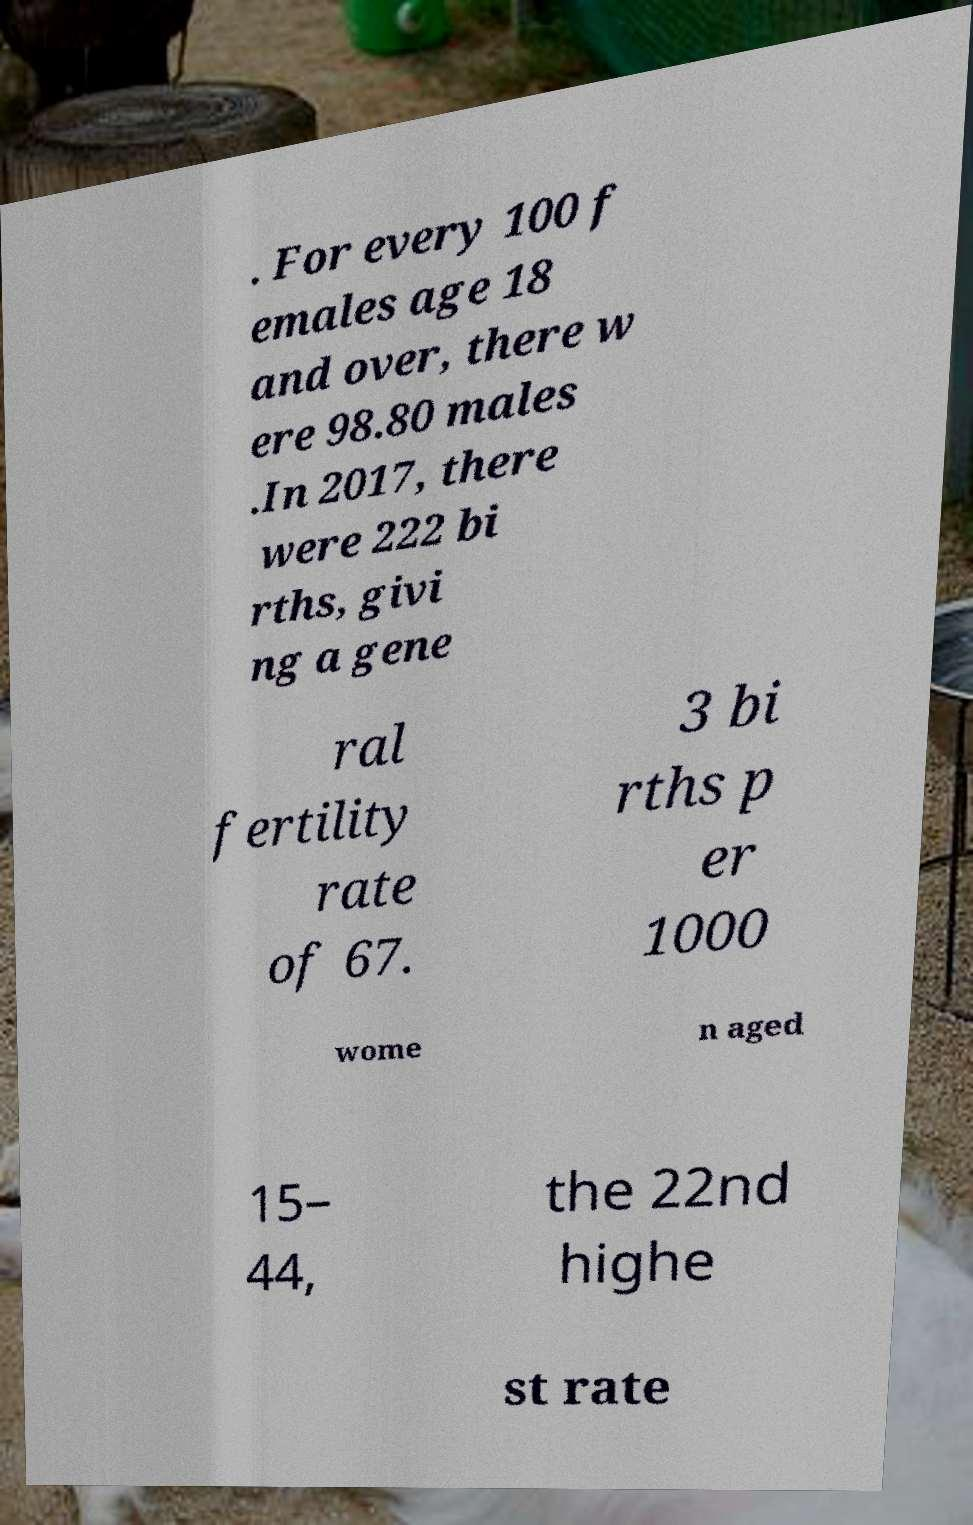Please identify and transcribe the text found in this image. . For every 100 f emales age 18 and over, there w ere 98.80 males .In 2017, there were 222 bi rths, givi ng a gene ral fertility rate of 67. 3 bi rths p er 1000 wome n aged 15– 44, the 22nd highe st rate 